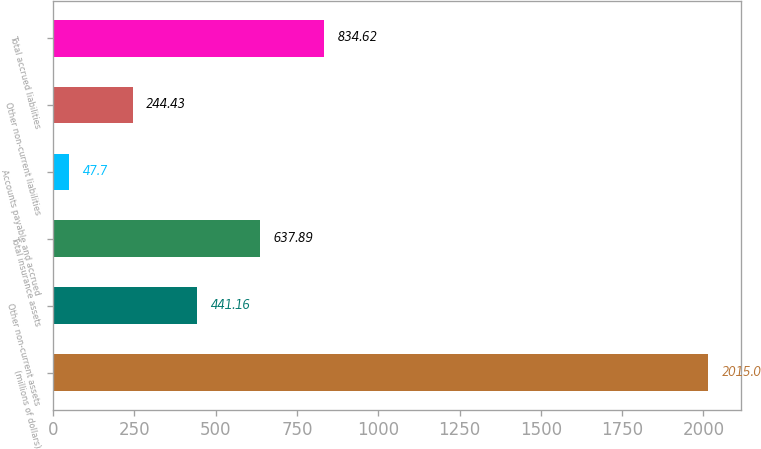Convert chart. <chart><loc_0><loc_0><loc_500><loc_500><bar_chart><fcel>(millions of dollars)<fcel>Other non-current assets<fcel>Total insurance assets<fcel>Accounts payable and accrued<fcel>Other non-current liabilities<fcel>Total accrued liabilities<nl><fcel>2015<fcel>441.16<fcel>637.89<fcel>47.7<fcel>244.43<fcel>834.62<nl></chart> 